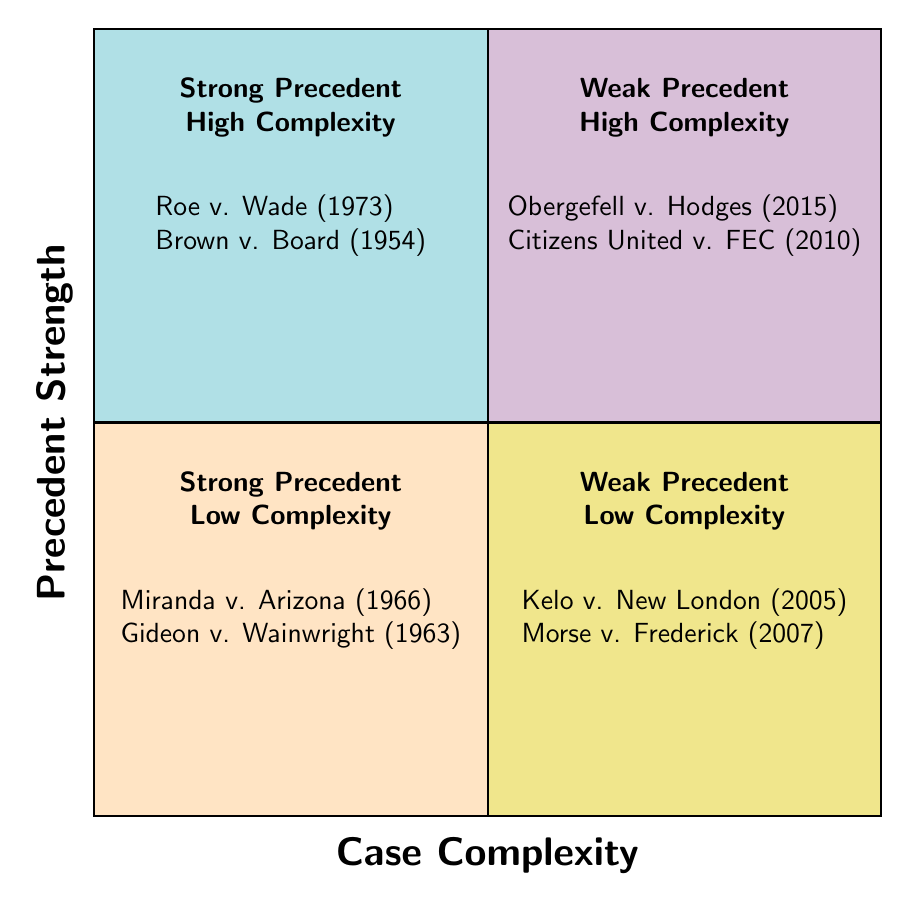What cases are in the "Strong Precedent & High Complexity" quadrant? The cases listed in this quadrant are "Roe v. Wade" and "Brown v. Board of Education." This information can be directly retrieved from the specific quadrant in the diagram.
Answer: Roe v. Wade, Brown v. Board of Education How many cases are categorized under "Weak Precedent & Low Complexity"? In the "Weak Precedent & Low Complexity" quadrant, there are two cases: "Kelo v. City of New London" and "Morse v. Frederick." Counting these cases gives the total.
Answer: 2 Which quadrant contains "Miranda v. Arizona"? "Miranda v. Arizona" is listed in the "Strong Precedent & Low Complexity" quadrant. This is determined by looking at the quadrant placements in the diagram.
Answer: Strong Precedent & Low Complexity What is the key point of "Obergefell v. Hodges"? The key point of "Obergefell v. Hodges," as noted in the quadrant, is "Same-sex marriage." This is a direct reading of the information available in that quadrant.
Answer: Same-sex marriage Are there more cases in the "Strong Precedent" quadrants than in the "Weak Precedent" quadrants? "Strong Precedent" has four cases in total (Roe v. Wade, Brown v. Board, Miranda v. Arizona, Gideon v. Wainwright), while "Weak Precedent" has four cases as well (Obergefell v. Hodges, Citizens United v. FEC, Kelo v. New London, Morse v. Frederick). Comparing these totals shows they are equal.
Answer: No What unique characteristic do the cases in "Weak Precedent & High Complexity" share? The cases in this quadrant, "Obergefell v. Hodges" and "Citizens United v. FEC," are characterized by their high complexity despite having weak precedents. This can be observed by the nature of the cases detailed within this quadrant.
Answer: High complexity What are the specific jurisdictions of the cases listed in the "Strong Precedent & Low Complexity" quadrant? The jurisdictions for "Miranda v. Arizona" and "Gideon v. Wainwright" are "U.S. Supreme Court." Both cases are under the same jurisdiction, which is stated in the quadrant alongside the case descriptions.
Answer: U.S. Supreme Court Which quadrant would you consider less significant for courtroom references? The "Weak Precedent & Low Complexity" quadrant may be considered less significant for courtroom references due to its combination of weak precedent and lower complexity overall in legal arguments. This evaluation is based on the characteristics defined in the quadrant.
Answer: Weak Precedent & Low Complexity 